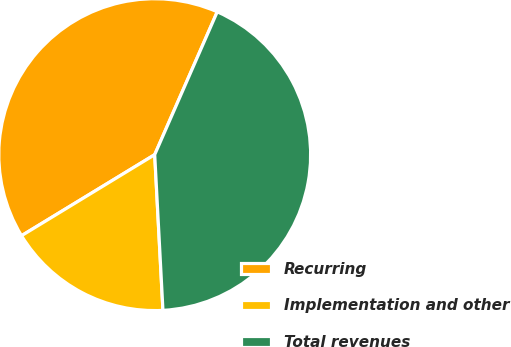Convert chart to OTSL. <chart><loc_0><loc_0><loc_500><loc_500><pie_chart><fcel>Recurring<fcel>Implementation and other<fcel>Total revenues<nl><fcel>40.27%<fcel>17.14%<fcel>42.59%<nl></chart> 